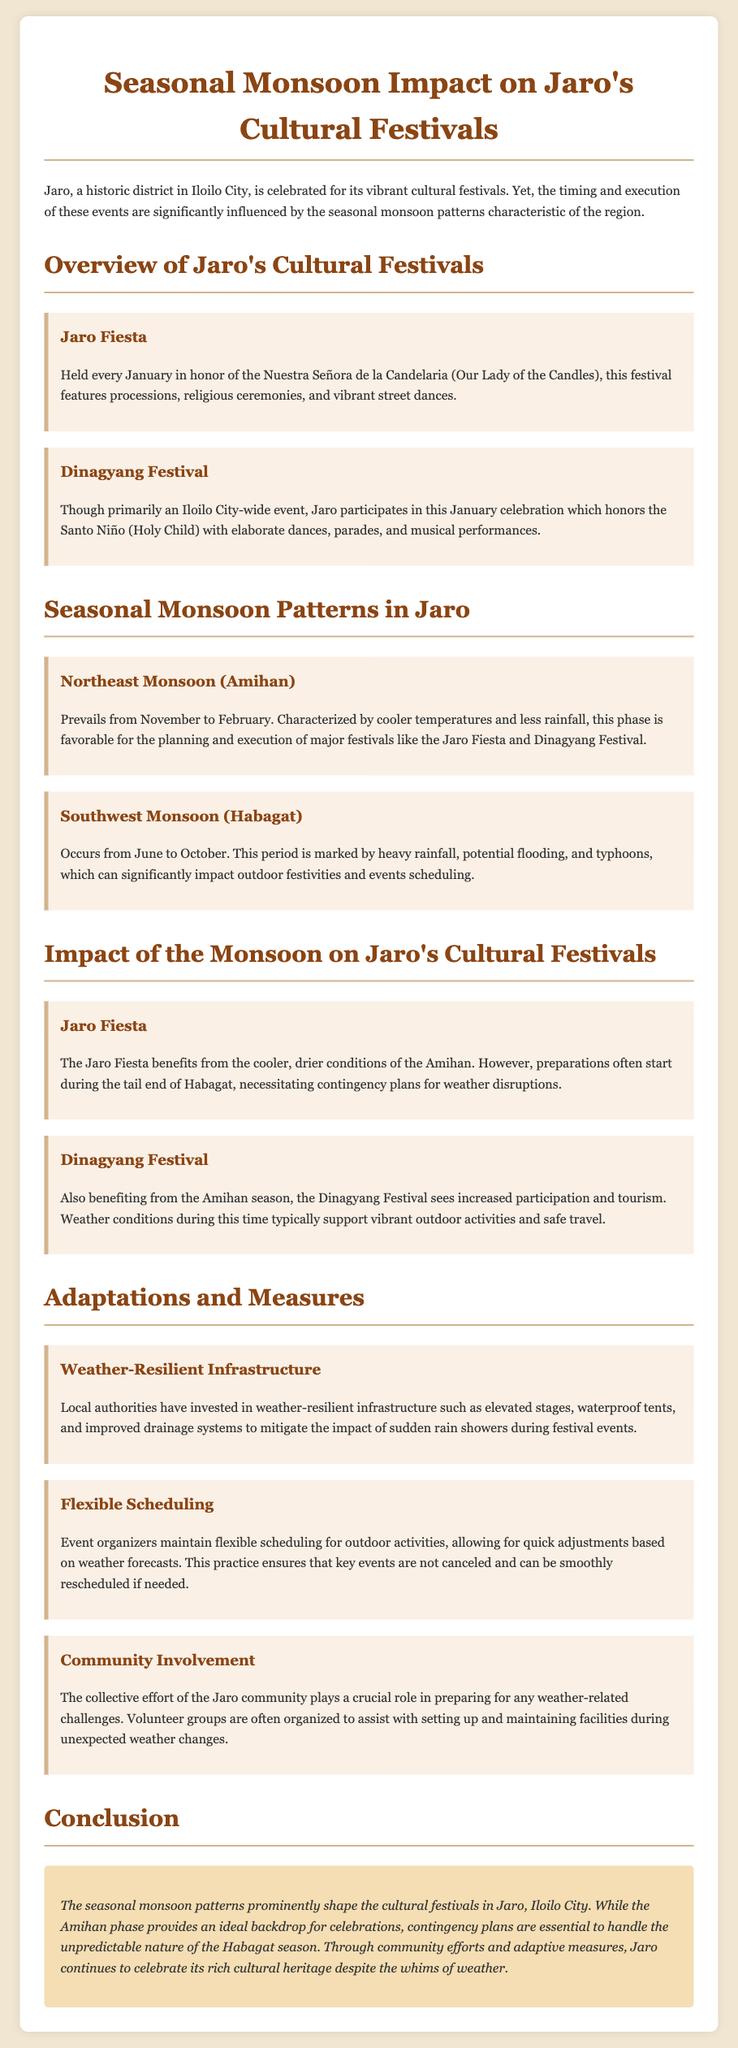What month is the Jaro Fiesta held? The Jaro Fiesta is held every January, honoring the Nuestra Señora de la Candelaria.
Answer: January Which festival in Jaro involves parades and musical performances? The Dinagyang Festival honors the Santo Niño with elaborate dances, parades, and musical performances.
Answer: Dinagyang Festival What period does the Northeast Monsoon (Amihan) prevail? The Northeast Monsoon (Amihan) prevails from November to February.
Answer: November to February How does the Habagat season affect outdoor festivities? The Southwest Monsoon (Habagat) occurs from June to October and is marked by heavy rainfall, which can significantly impact outdoor festivities.
Answer: Heavy rainfall What measures are taken to handle unexpected rain during festivals? Local authorities invest in weather-resilient infrastructure such as elevated stages, waterproof tents, and improved drainage systems to mitigate the impact of sudden rain showers.
Answer: Weather-resilient infrastructure How do event organizers ensure festivals are not canceled? Event organizers maintain flexible scheduling for outdoor activities, allowing for quick adjustments based on weather forecasts.
Answer: Flexible scheduling What role does community involvement play in festival preparations? The collective effort of the Jaro community plays a crucial role in preparing for any weather-related challenges.
Answer: Community involvement What is the cultural significance of the festivals in Jaro? The seasonal monsoon patterns prominently shape the cultural festivals in Jaro, Iloilo City, showcasing its rich cultural heritage.
Answer: Cultural heritage 